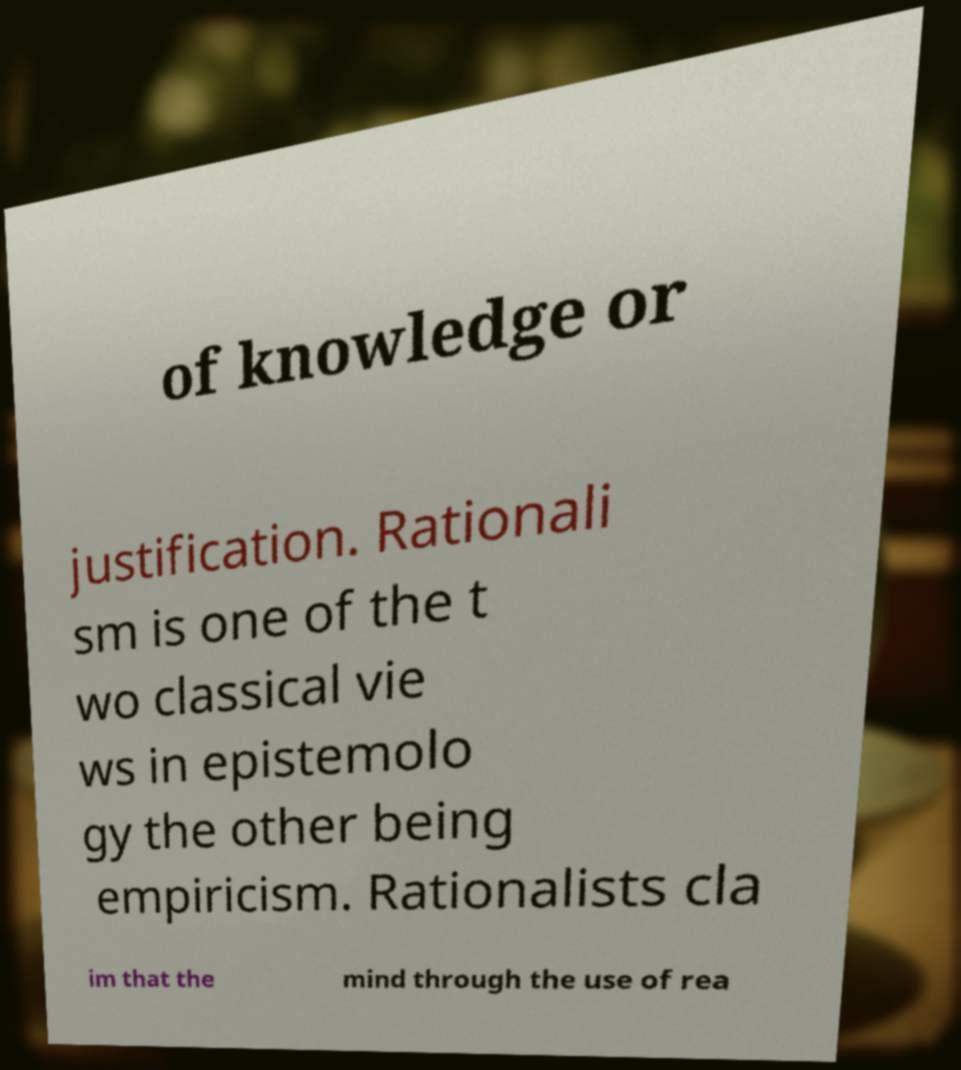I need the written content from this picture converted into text. Can you do that? of knowledge or justification. Rationali sm is one of the t wo classical vie ws in epistemolo gy the other being empiricism. Rationalists cla im that the mind through the use of rea 